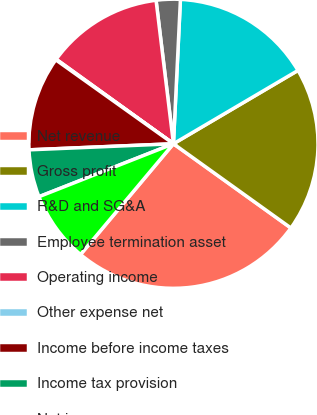Convert chart. <chart><loc_0><loc_0><loc_500><loc_500><pie_chart><fcel>Net revenue<fcel>Gross profit<fcel>R&D and SG&A<fcel>Employee termination asset<fcel>Operating income<fcel>Other expense net<fcel>Income before income taxes<fcel>Income tax provision<fcel>Net income<nl><fcel>26.21%<fcel>18.37%<fcel>15.76%<fcel>2.69%<fcel>13.14%<fcel>0.08%<fcel>10.53%<fcel>5.3%<fcel>7.92%<nl></chart> 